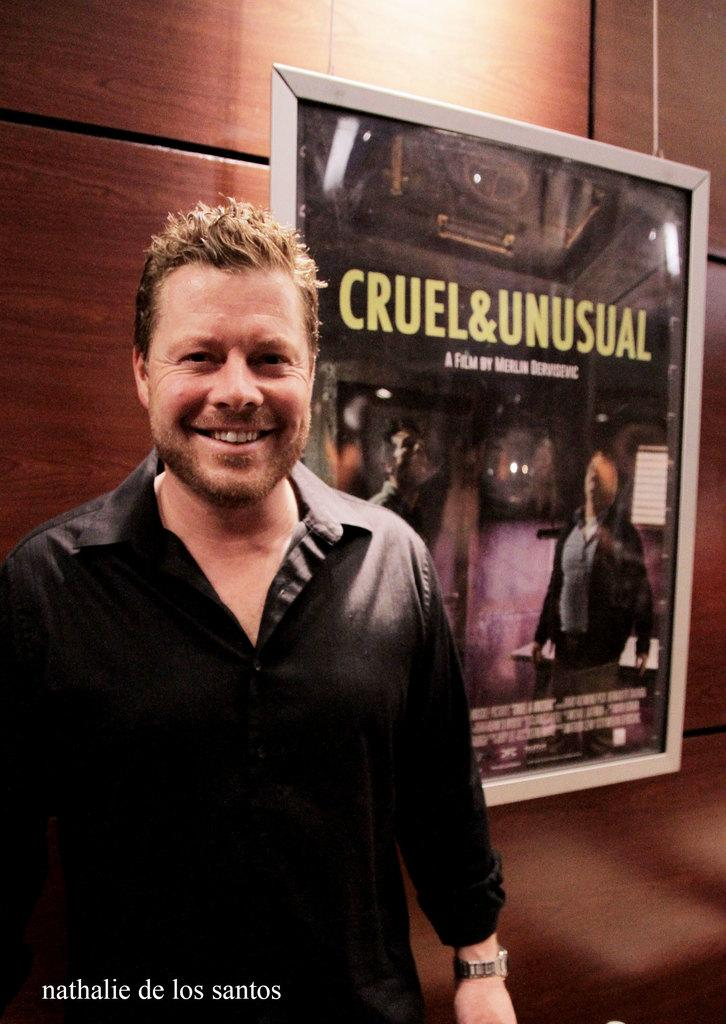Who is present in the image? There is a person in the image. What is the person wearing? The person is wearing a black dress. What can be seen around the person in the image? There is a frame visible in the image. What color is the wall in the background of the image? There is a brown wall in the background of the image. What type of engine can be heard in the background of the image? There is no engine or sound present in the image; it is a still image of a person wearing a black dress with a frame and a brown wall in the background. 